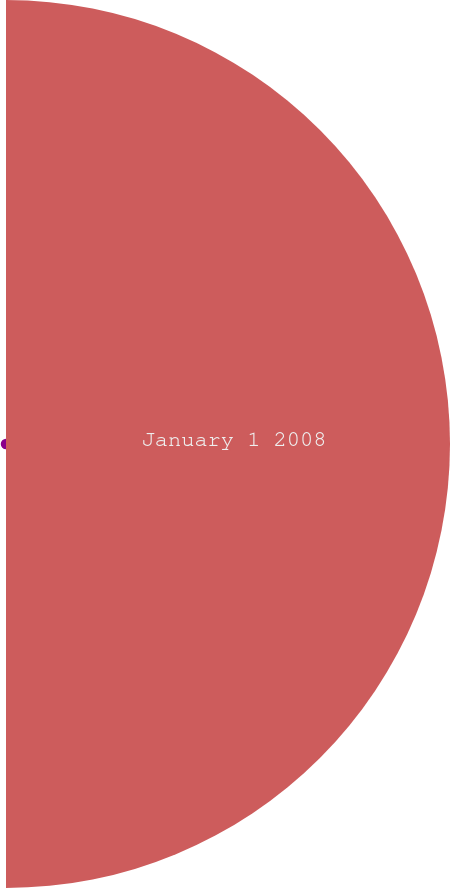<chart> <loc_0><loc_0><loc_500><loc_500><pie_chart><fcel>January 1 2008<fcel>Total realized/unrealized<nl><fcel>98.83%<fcel>1.17%<nl></chart> 